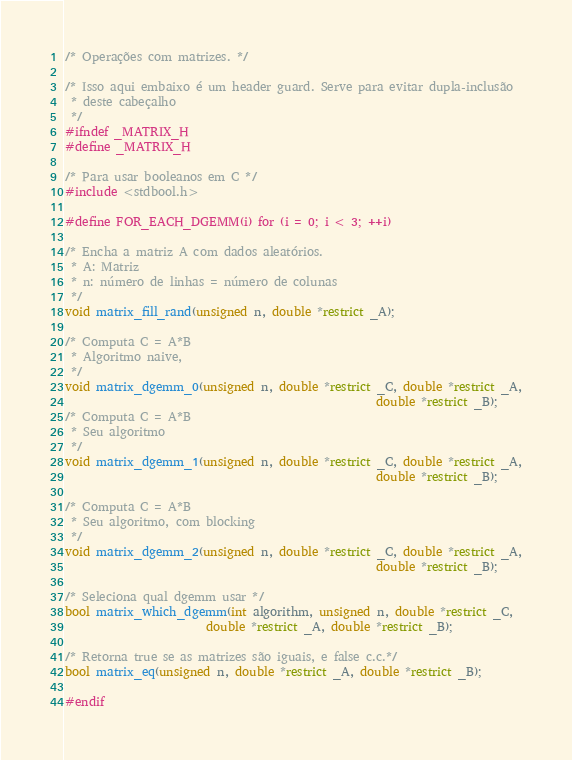Convert code to text. <code><loc_0><loc_0><loc_500><loc_500><_C_>/* Operações com matrizes. */

/* Isso aqui embaixo é um header guard. Serve para evitar dupla-inclusão
 * deste cabeçalho
 */
#ifndef _MATRIX_H
#define _MATRIX_H

/* Para usar booleanos em C */
#include <stdbool.h>

#define FOR_EACH_DGEMM(i) for (i = 0; i < 3; ++i)

/* Encha a matriz A com dados aleatórios.
 * A: Matriz
 * n: número de linhas = número de colunas
 */
void matrix_fill_rand(unsigned n, double *restrict _A);

/* Computa C = A*B
 * Algoritmo naive,
 */
void matrix_dgemm_0(unsigned n, double *restrict _C, double *restrict _A,
                                                     double *restrict _B);
/* Computa C = A*B
 * Seu algoritmo
 */
void matrix_dgemm_1(unsigned n, double *restrict _C, double *restrict _A,
                                                     double *restrict _B);

/* Computa C = A*B
 * Seu algoritmo, com blocking
 */
void matrix_dgemm_2(unsigned n, double *restrict _C, double *restrict _A,
                                                     double *restrict _B);

/* Seleciona qual dgemm usar */
bool matrix_which_dgemm(int algorithm, unsigned n, double *restrict _C,
                        double *restrict _A, double *restrict _B);

/* Retorna true se as matrizes são iguais, e false c.c.*/
bool matrix_eq(unsigned n, double *restrict _A, double *restrict _B);

#endif
</code> 